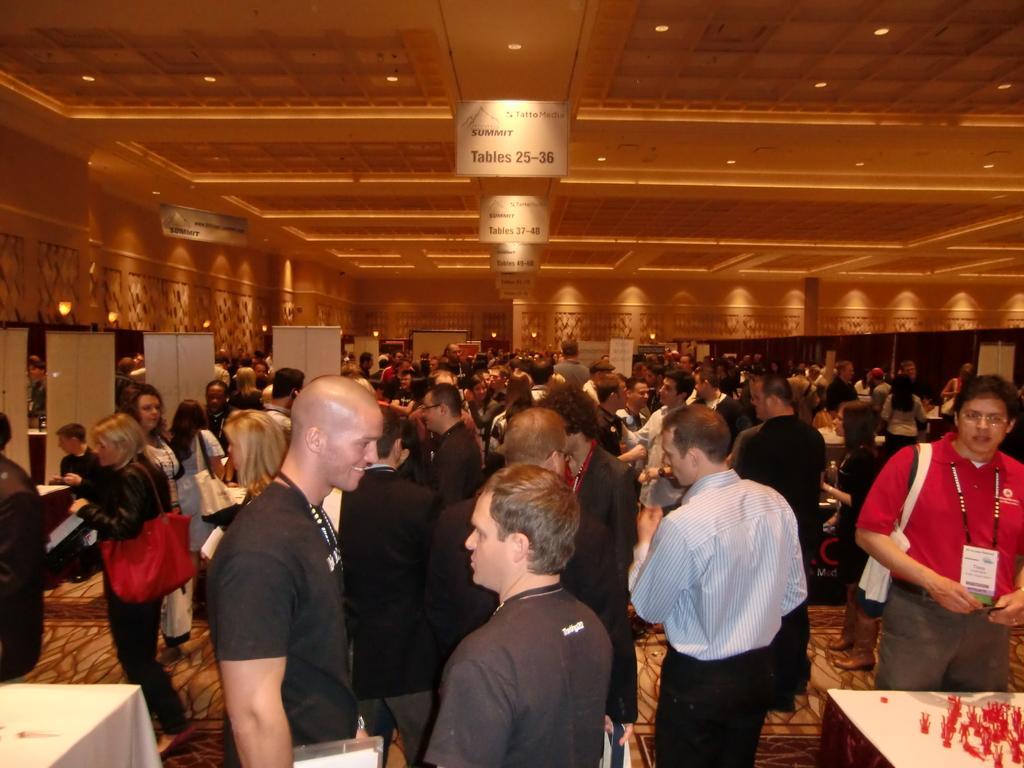Can you describe this image briefly? This is the picture of a room. In this picture there are group of people standing. On the left side of the image there are doors. At the top there are lights and there are boards and there is a text on the board. At the bottom there are tables. 